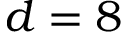Convert formula to latex. <formula><loc_0><loc_0><loc_500><loc_500>d = 8</formula> 